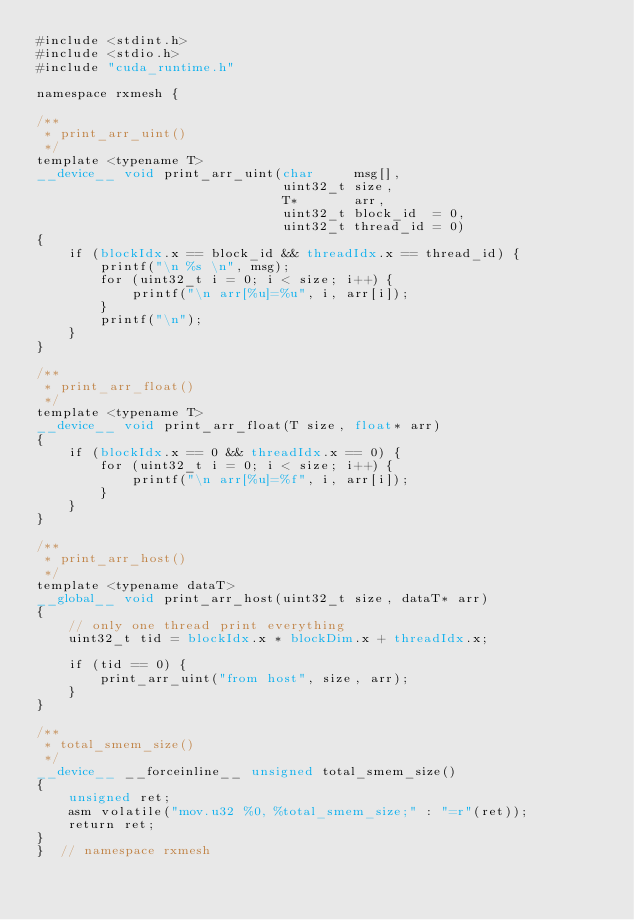<code> <loc_0><loc_0><loc_500><loc_500><_Cuda_>#include <stdint.h>
#include <stdio.h>
#include "cuda_runtime.h"

namespace rxmesh {

/**
 * print_arr_uint()
 */
template <typename T>
__device__ void print_arr_uint(char     msg[],
                               uint32_t size,
                               T*       arr,
                               uint32_t block_id  = 0,
                               uint32_t thread_id = 0)
{
    if (blockIdx.x == block_id && threadIdx.x == thread_id) {
        printf("\n %s \n", msg);
        for (uint32_t i = 0; i < size; i++) {
            printf("\n arr[%u]=%u", i, arr[i]);
        }
        printf("\n");
    }
}

/**
 * print_arr_float()
 */
template <typename T>
__device__ void print_arr_float(T size, float* arr)
{
    if (blockIdx.x == 0 && threadIdx.x == 0) {
        for (uint32_t i = 0; i < size; i++) {
            printf("\n arr[%u]=%f", i, arr[i]);
        }
    }
}

/**
 * print_arr_host()
 */
template <typename dataT>
__global__ void print_arr_host(uint32_t size, dataT* arr)
{
    // only one thread print everything
    uint32_t tid = blockIdx.x * blockDim.x + threadIdx.x;

    if (tid == 0) {
        print_arr_uint("from host", size, arr);
    }
}

/**
 * total_smem_size()
 */
__device__ __forceinline__ unsigned total_smem_size()
{
    unsigned ret;
    asm volatile("mov.u32 %0, %total_smem_size;" : "=r"(ret));
    return ret;
}
}  // namespace rxmesh</code> 